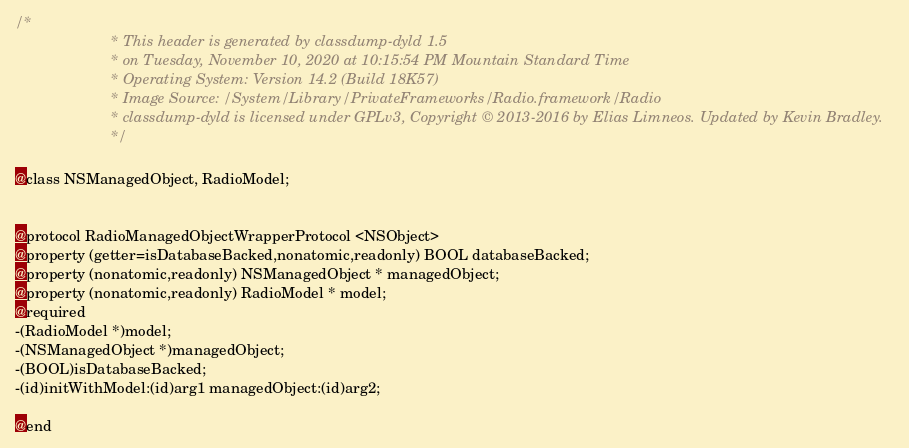Convert code to text. <code><loc_0><loc_0><loc_500><loc_500><_C_>/*
                       * This header is generated by classdump-dyld 1.5
                       * on Tuesday, November 10, 2020 at 10:15:54 PM Mountain Standard Time
                       * Operating System: Version 14.2 (Build 18K57)
                       * Image Source: /System/Library/PrivateFrameworks/Radio.framework/Radio
                       * classdump-dyld is licensed under GPLv3, Copyright © 2013-2016 by Elias Limneos. Updated by Kevin Bradley.
                       */

@class NSManagedObject, RadioModel;


@protocol RadioManagedObjectWrapperProtocol <NSObject>
@property (getter=isDatabaseBacked,nonatomic,readonly) BOOL databaseBacked; 
@property (nonatomic,readonly) NSManagedObject * managedObject; 
@property (nonatomic,readonly) RadioModel * model; 
@required
-(RadioModel *)model;
-(NSManagedObject *)managedObject;
-(BOOL)isDatabaseBacked;
-(id)initWithModel:(id)arg1 managedObject:(id)arg2;

@end

</code> 